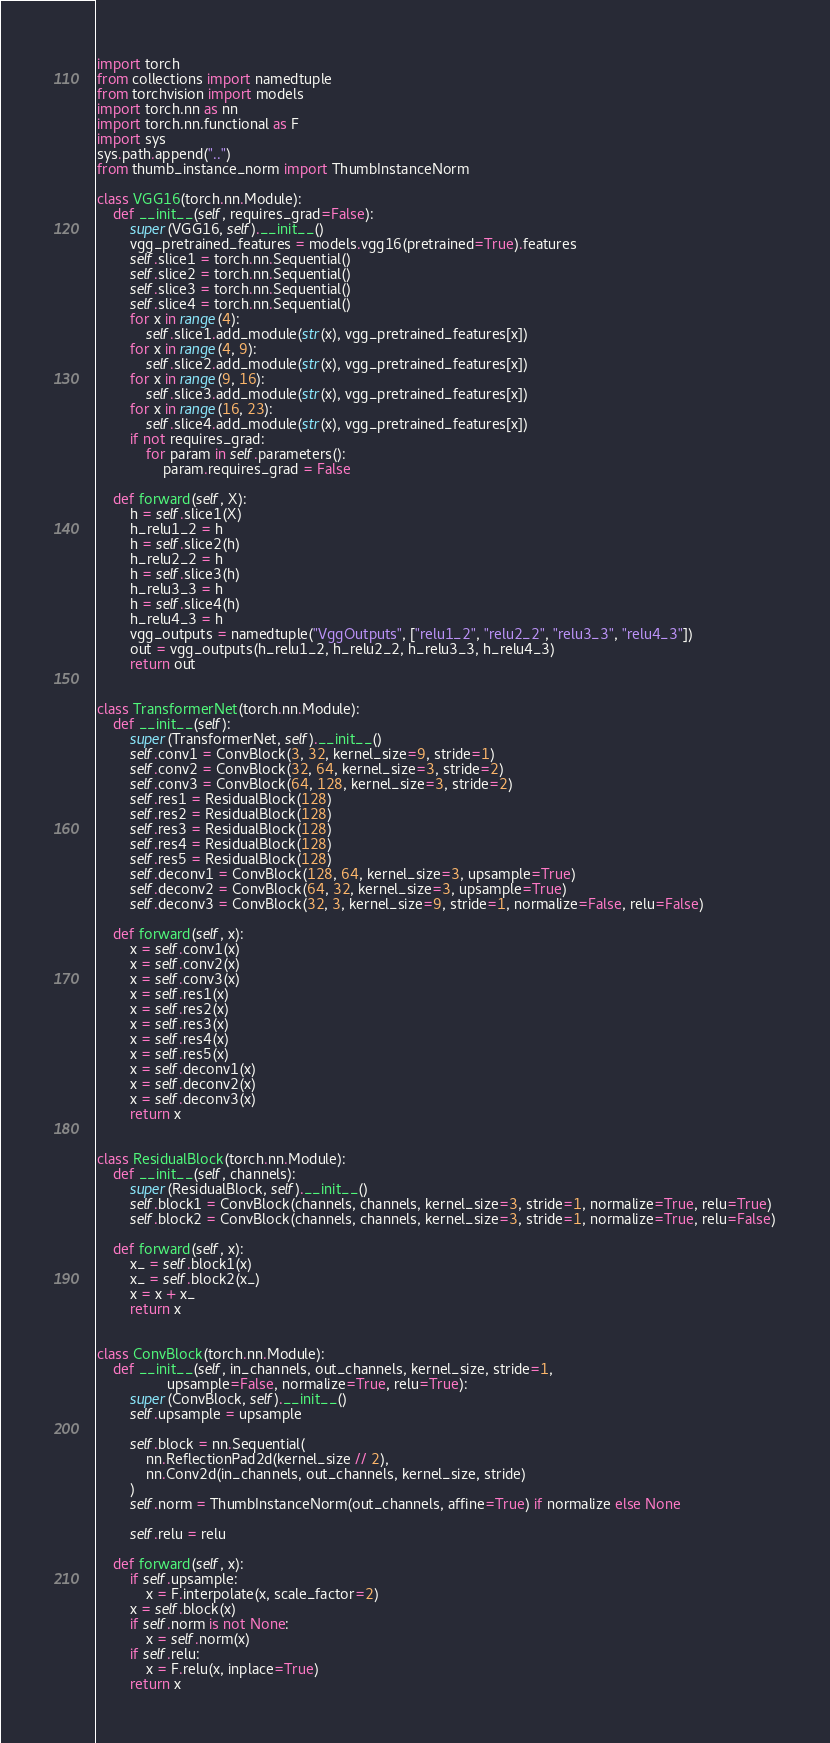Convert code to text. <code><loc_0><loc_0><loc_500><loc_500><_Python_>import torch
from collections import namedtuple
from torchvision import models
import torch.nn as nn
import torch.nn.functional as F
import sys
sys.path.append("..")
from thumb_instance_norm import ThumbInstanceNorm

class VGG16(torch.nn.Module):
    def __init__(self, requires_grad=False):
        super(VGG16, self).__init__()
        vgg_pretrained_features = models.vgg16(pretrained=True).features
        self.slice1 = torch.nn.Sequential()
        self.slice2 = torch.nn.Sequential()
        self.slice3 = torch.nn.Sequential()
        self.slice4 = torch.nn.Sequential()
        for x in range(4):
            self.slice1.add_module(str(x), vgg_pretrained_features[x])
        for x in range(4, 9):
            self.slice2.add_module(str(x), vgg_pretrained_features[x])
        for x in range(9, 16):
            self.slice3.add_module(str(x), vgg_pretrained_features[x])
        for x in range(16, 23):
            self.slice4.add_module(str(x), vgg_pretrained_features[x])
        if not requires_grad:
            for param in self.parameters():
                param.requires_grad = False
    
    def forward(self, X):
        h = self.slice1(X)
        h_relu1_2 = h
        h = self.slice2(h)
        h_relu2_2 = h
        h = self.slice3(h)
        h_relu3_3 = h
        h = self.slice4(h)
        h_relu4_3 = h
        vgg_outputs = namedtuple("VggOutputs", ["relu1_2", "relu2_2", "relu3_3", "relu4_3"])
        out = vgg_outputs(h_relu1_2, h_relu2_2, h_relu3_3, h_relu4_3)
        return out


class TransformerNet(torch.nn.Module):
    def __init__(self):
        super(TransformerNet, self).__init__()
        self.conv1 = ConvBlock(3, 32, kernel_size=9, stride=1)
        self.conv2 = ConvBlock(32, 64, kernel_size=3, stride=2)
        self.conv3 = ConvBlock(64, 128, kernel_size=3, stride=2)
        self.res1 = ResidualBlock(128)
        self.res2 = ResidualBlock(128)
        self.res3 = ResidualBlock(128)
        self.res4 = ResidualBlock(128)
        self.res5 = ResidualBlock(128)
        self.deconv1 = ConvBlock(128, 64, kernel_size=3, upsample=True)
        self.deconv2 = ConvBlock(64, 32, kernel_size=3, upsample=True)
        self.deconv3 = ConvBlock(32, 3, kernel_size=9, stride=1, normalize=False, relu=False)
    
    def forward(self, x):
        x = self.conv1(x)
        x = self.conv2(x)
        x = self.conv3(x)
        x = self.res1(x)
        x = self.res2(x)
        x = self.res3(x)
        x = self.res4(x)
        x = self.res5(x)
        x = self.deconv1(x)
        x = self.deconv2(x)
        x = self.deconv3(x)
        return x


class ResidualBlock(torch.nn.Module):
    def __init__(self, channels):
        super(ResidualBlock, self).__init__()
        self.block1 = ConvBlock(channels, channels, kernel_size=3, stride=1, normalize=True, relu=True)
        self.block2 = ConvBlock(channels, channels, kernel_size=3, stride=1, normalize=True, relu=False)
    
    def forward(self, x):
        x_ = self.block1(x)
        x_ = self.block2(x_)
        x = x + x_
        return x


class ConvBlock(torch.nn.Module):
    def __init__(self, in_channels, out_channels, kernel_size, stride=1,
                 upsample=False, normalize=True, relu=True):
        super(ConvBlock, self).__init__()
        self.upsample = upsample
        
        self.block = nn.Sequential(
            nn.ReflectionPad2d(kernel_size // 2),
            nn.Conv2d(in_channels, out_channels, kernel_size, stride)
        )
        self.norm = ThumbInstanceNorm(out_channels, affine=True) if normalize else None
        
        self.relu = relu
    
    def forward(self, x):
        if self.upsample:
            x = F.interpolate(x, scale_factor=2)
        x = self.block(x)
        if self.norm is not None:
            x = self.norm(x)
        if self.relu:
            x = F.relu(x, inplace=True)
        return x


</code> 